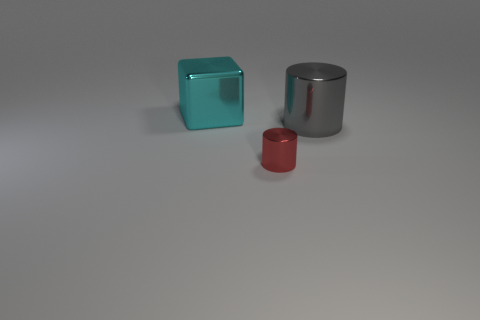What materials do the objects in the image seem to be made of? The objects in the image appear to be made of a reflective, metallic material, suggesting a composition of metal or a similarly reflective synthetic substance, which gives them a sleek, contemporary appearance. How does lighting affect the appearance of these objects? The lighting creates a soft glow on the surfaces of the objects, highlighting their reflective qualities and smooth finishes. It casts subtle shadows on the ground, contributing to a three-dimensional effect that accentuates their shapes. 